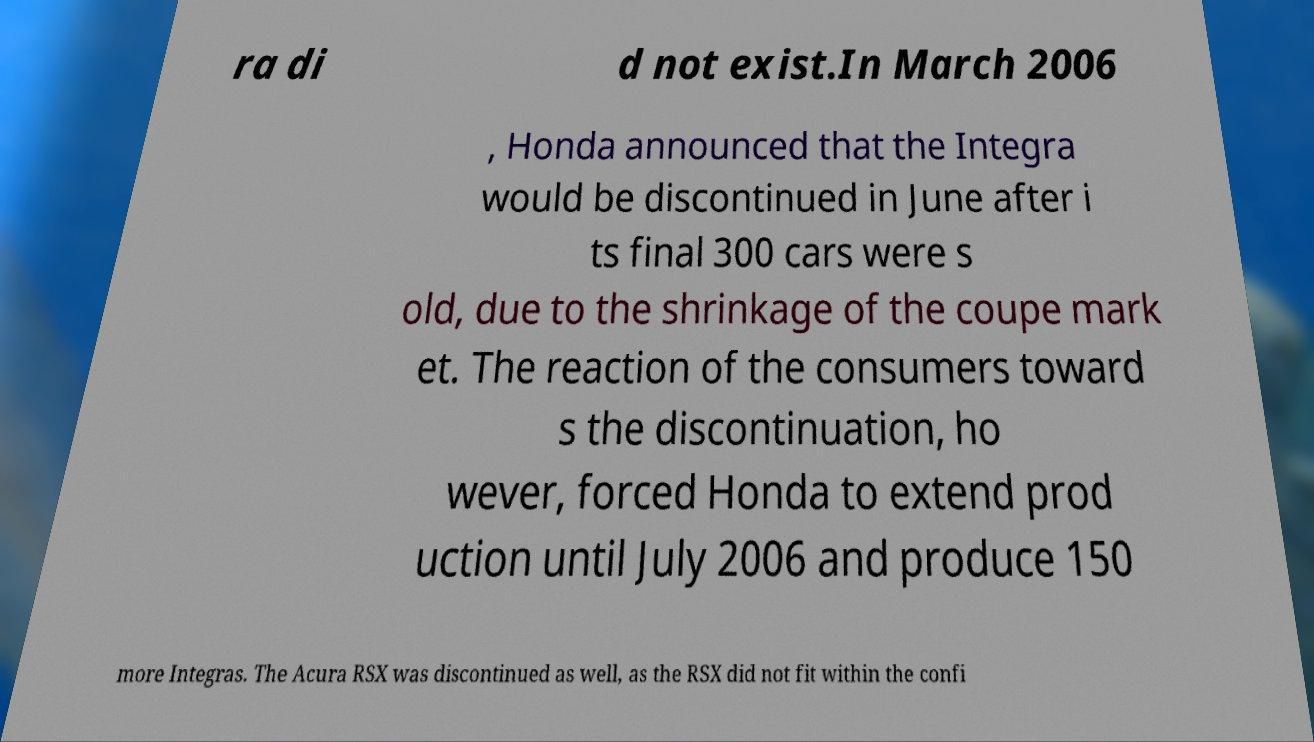What messages or text are displayed in this image? I need them in a readable, typed format. ra di d not exist.In March 2006 , Honda announced that the Integra would be discontinued in June after i ts final 300 cars were s old, due to the shrinkage of the coupe mark et. The reaction of the consumers toward s the discontinuation, ho wever, forced Honda to extend prod uction until July 2006 and produce 150 more Integras. The Acura RSX was discontinued as well, as the RSX did not fit within the confi 